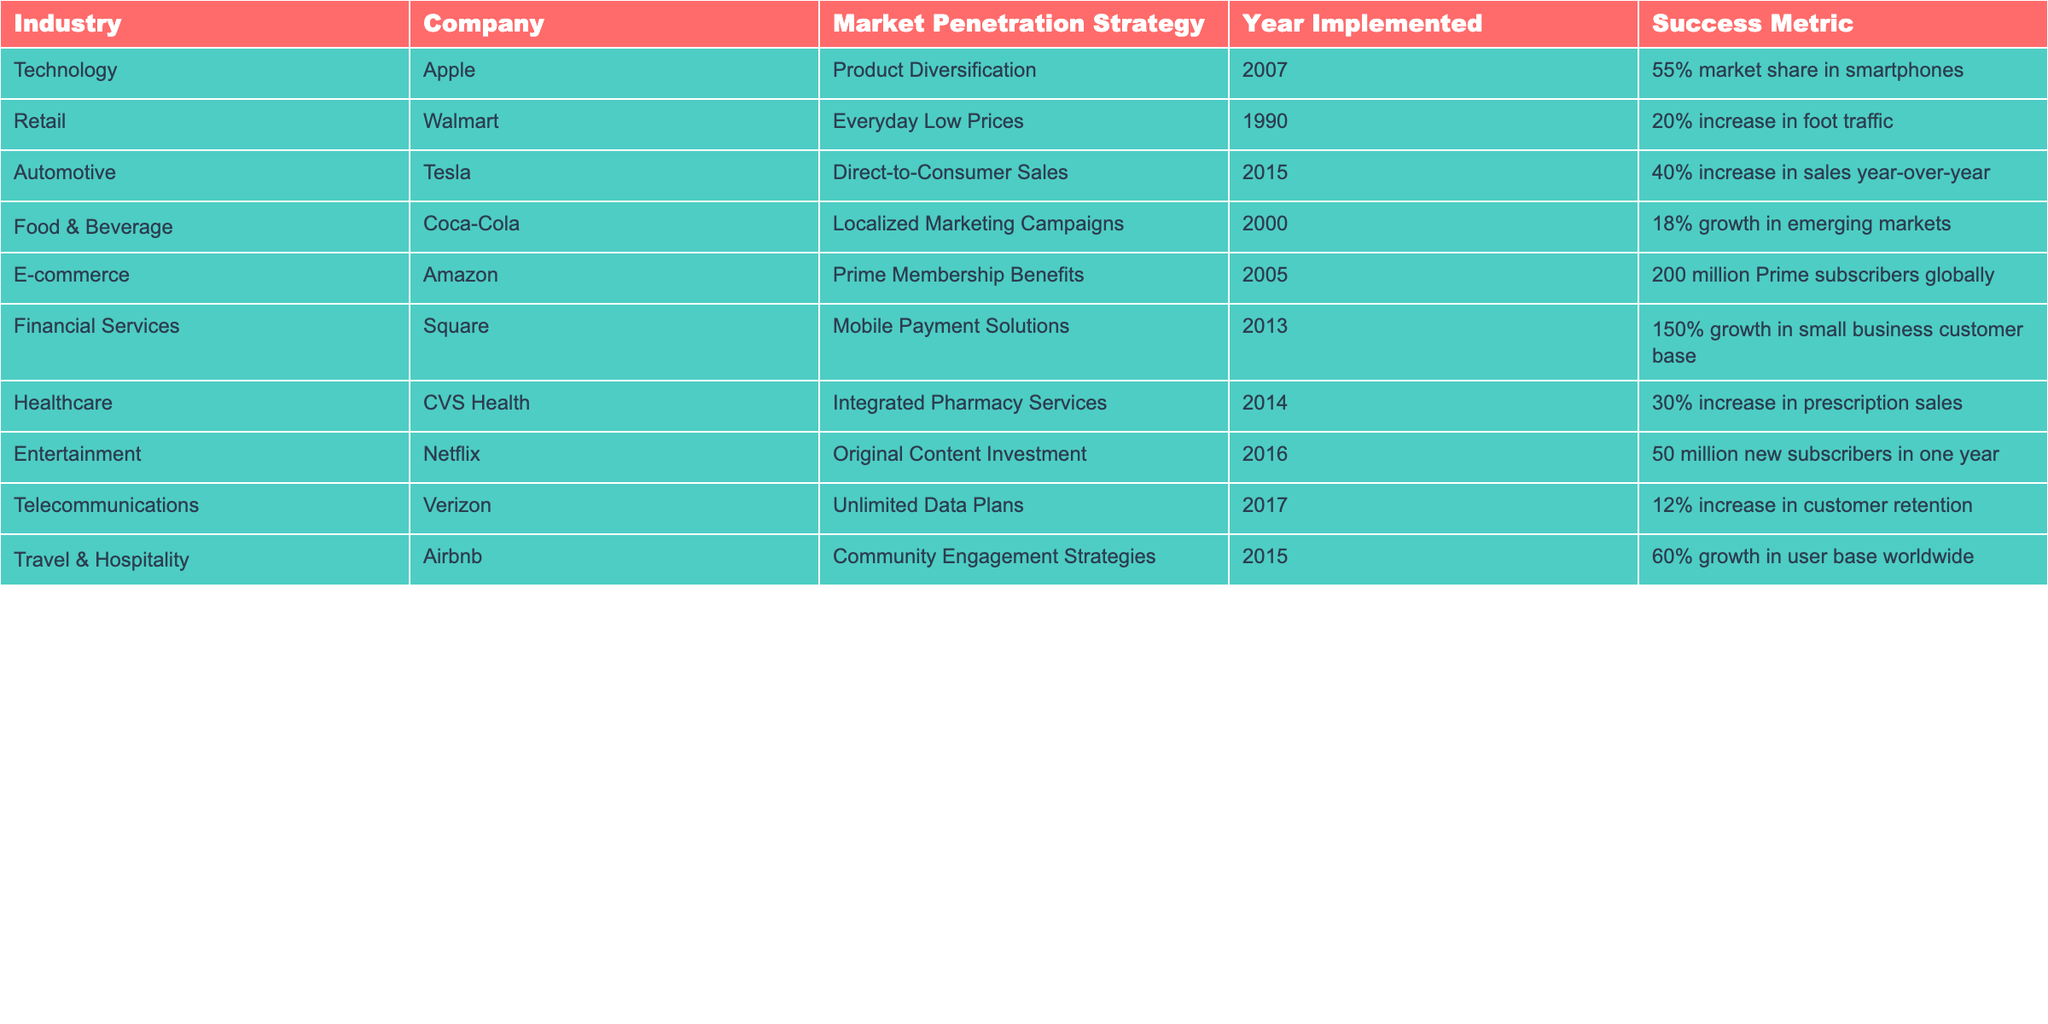What market penetration strategy did Apple implement in 2007? The table shows that Apple implemented Product Diversification as their market penetration strategy in the year 2007.
Answer: Product Diversification Which company experienced a 20% increase in foot traffic due to their market penetration strategy? According to the table, Walmart implemented Everyday Low Prices and experienced a 20% increase in foot traffic.
Answer: Walmart What is the success metric for Tesla's market penetration strategy? The table indicates that Tesla's Direct-to-Consumer Sales strategy resulted in a 40% increase in sales year-over-year.
Answer: 40% increase in sales year-over-year In which industry did Square implement their market penetration strategy? The table shows that Square's Mobile Payment Solutions were implemented in the Financial Services industry.
Answer: Financial Services Which two companies had a market penetration strategy that involved an increase in user base? The table indicates that Airbnb had a 60% growth in user base worldwide and Netflix gained 50 million new subscribers in one year from their respective strategies.
Answer: Airbnb and Netflix What percentage growth did CVS Health achieve in prescription sales? The table states that CVS Health's Integrated Pharmacy Services led to a 30% increase in prescription sales.
Answer: 30% Is it true that Coca-Cola's market penetration strategy was implemented after 2010? The data shows that Coca-Cola's Localized Marketing Campaigns were implemented in 2000, which is before 2010. Thus, the statement is false.
Answer: No Which company's strategy was focused on community engagement, and what was the success metric? The table shows that Airbnb implemented Community Engagement Strategies and achieved a 60% growth in their user base worldwide.
Answer: Airbnb, 60% growth in user base How does the success metric of Amazon's strategy compare with that of CVS Health? Amazon's Prime Membership Benefits resulted in 200 million Prime subscribers globally, while CVS Health achieved a 30% increase in prescription sales. The metrics are different types (subscribers vs sales increase), but Amazon’s metric indicates a significantly larger scale.
Answer: 200 million vs 30% What was the earliest year in which a market penetration strategy was implemented, and which company was it? According to the table, the earliest year for a market penetration strategy is 2000 by Coca-Cola with their Localized Marketing Campaigns.
Answer: 2000, Coca-Cola 